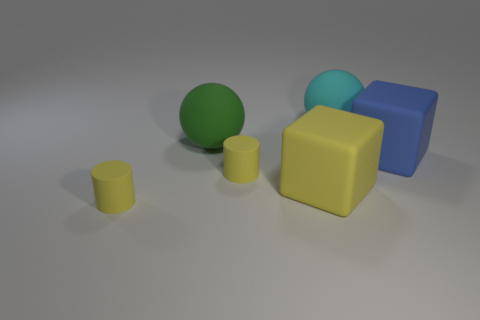There is a tiny cylinder in front of the yellow block; what number of cylinders are behind it?
Your answer should be very brief. 1. Does the big green matte thing have the same shape as the blue object?
Your answer should be compact. No. There is a green rubber object; does it have the same shape as the small object to the right of the large green ball?
Offer a terse response. No. There is a cylinder behind the small yellow matte thing to the left of the big matte object left of the large yellow block; what is its color?
Keep it short and to the point. Yellow. Do the small yellow object in front of the big yellow matte object and the large cyan rubber thing have the same shape?
Provide a succinct answer. No. What is the material of the large green ball?
Offer a terse response. Rubber. There is a small thing in front of the cube in front of the matte object right of the cyan rubber ball; what shape is it?
Your answer should be very brief. Cylinder. What number of other things are there of the same shape as the cyan matte object?
Provide a succinct answer. 1. How many objects are there?
Offer a very short reply. 6. What number of things are matte blocks or large brown spheres?
Offer a very short reply. 2. 